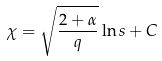Convert formula to latex. <formula><loc_0><loc_0><loc_500><loc_500>\chi = \sqrt { \frac { 2 + \alpha } { q } } \ln s + C</formula> 